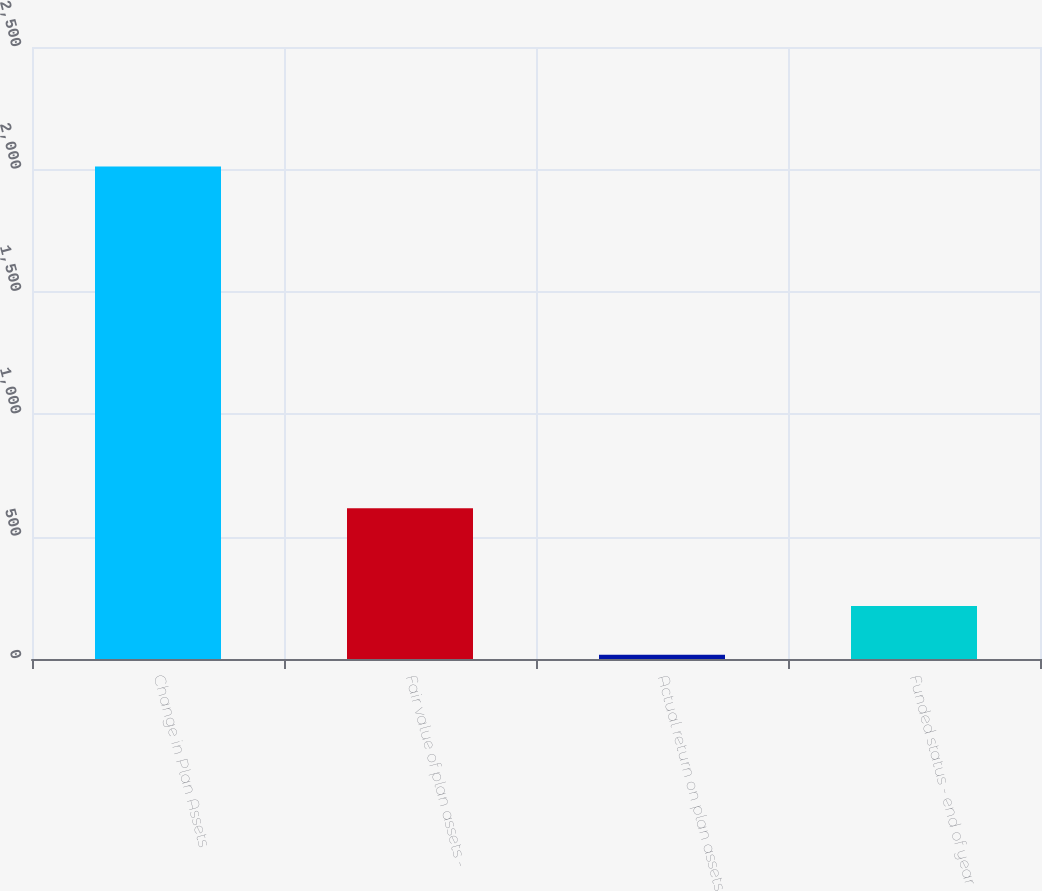Convert chart to OTSL. <chart><loc_0><loc_0><loc_500><loc_500><bar_chart><fcel>Change in Plan Assets<fcel>Fair value of plan assets -<fcel>Actual return on plan assets<fcel>Funded status - end of year<nl><fcel>2012<fcel>615.5<fcel>17<fcel>216.5<nl></chart> 